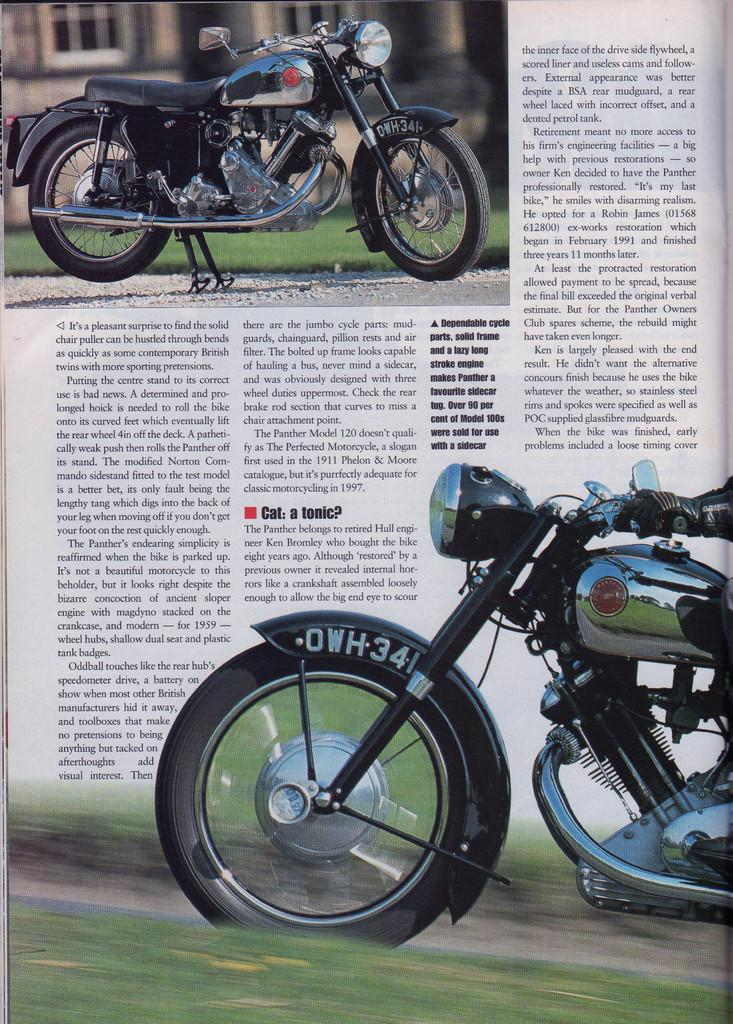What is present in the image that contains visual information? There is a paper in the image that contains visual information. What type of vehicle is depicted on the paper? The paper contains images of a motorbike. Is there any text on the paper? Yes, there is text printed on the paper. How many ants can be seen crawling on the motorbike in the image? There are no ants present in the image; it only contains images of a motorbike and text on a paper. What type of bird is perched on the tent in the image? There is no tent or bird present in the image. 